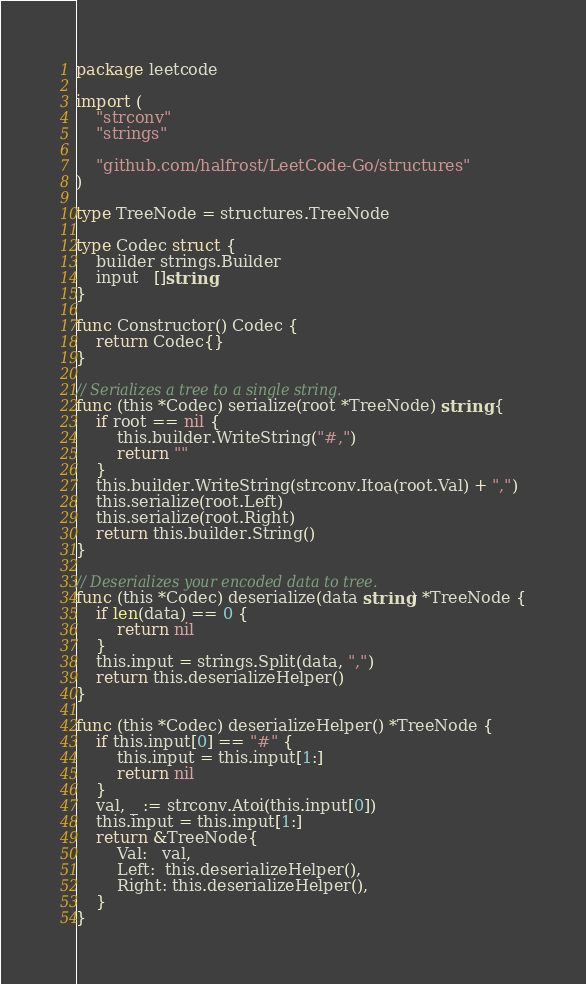Convert code to text. <code><loc_0><loc_0><loc_500><loc_500><_Go_>package leetcode

import (
	"strconv"
	"strings"

	"github.com/halfrost/LeetCode-Go/structures"
)

type TreeNode = structures.TreeNode

type Codec struct {
	builder strings.Builder
	input   []string
}

func Constructor() Codec {
	return Codec{}
}

// Serializes a tree to a single string.
func (this *Codec) serialize(root *TreeNode) string {
	if root == nil {
		this.builder.WriteString("#,")
		return ""
	}
	this.builder.WriteString(strconv.Itoa(root.Val) + ",")
	this.serialize(root.Left)
	this.serialize(root.Right)
	return this.builder.String()
}

// Deserializes your encoded data to tree.
func (this *Codec) deserialize(data string) *TreeNode {
	if len(data) == 0 {
		return nil
	}
	this.input = strings.Split(data, ",")
	return this.deserializeHelper()
}

func (this *Codec) deserializeHelper() *TreeNode {
	if this.input[0] == "#" {
		this.input = this.input[1:]
		return nil
	}
	val, _ := strconv.Atoi(this.input[0])
	this.input = this.input[1:]
	return &TreeNode{
		Val:   val,
		Left:  this.deserializeHelper(),
		Right: this.deserializeHelper(),
	}
}
</code> 